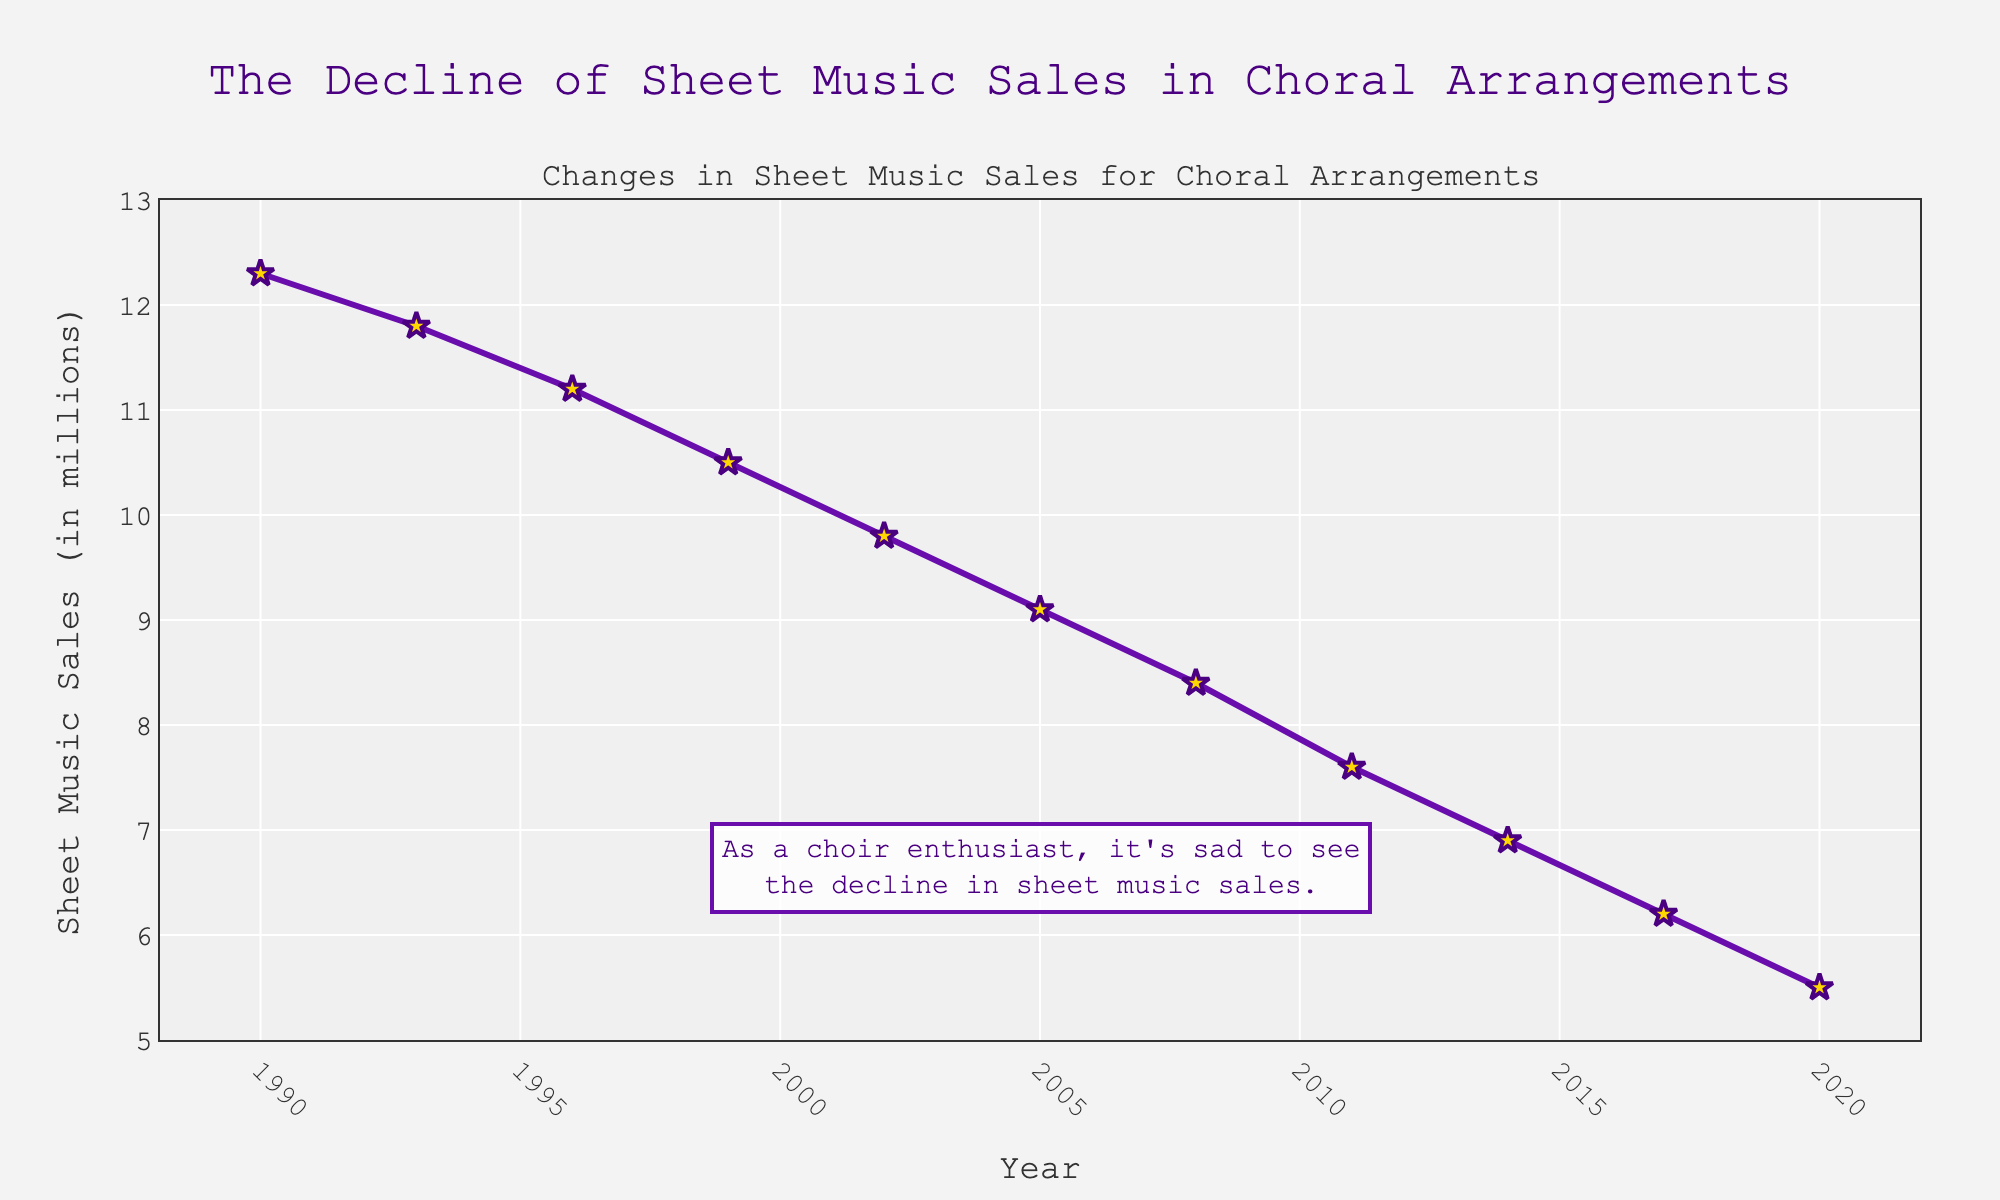What's the overall trend of sheet music sales for choral arrangements from 1990 to 2020? The overall trend of the sheet music sales for choral arrangements from 1990 to 2020 shows a consistent decline. By looking at the plotted line, it consistently drops over time.
Answer: Decline By how much did sheet music sales decrease between 1990 and 2020? In 1990, the sales were 12.3 million, and in 2020, they were 5.5 million. To find the decrease, subtract the 2020 value from the 1990 value: 12.3 - 5.5 = 6.8 million.
Answer: 6.8 million In which three-year period did sheet music sales decline the most, and by how much? Check the differences between sales every three years: 
1990-1993: 12.3 - 11.8 = 0.5 
1993-1996: 11.8 - 11.2 = 0.6 
1996-1999: 11.2 - 10.5 = 0.7 
1999-2002: 10.5 - 9.8 = 0.7 
2002-2005: 9.8 - 9.1 = 0.7 
2005-2008: 9.1 - 8.4 = 0.7 
2008-2011: 8.4 - 7.6 = 0.8 
2011-2014: 7.6 - 6.9 = 0.7 
2014-2017: 6.9 - 6.2 = 0.7 
2017-2020: 6.2 - 5.5 = 0.7 
The period with the largest decline is 2008-2011 with a decrease of 0.8 million.
Answer: 2008-2011, 0.8 million What is the average sheet music sales per year for the first decade (1990-2000)? Add the sales from each year in the first decade and divide by the number of years: 
(12.3 + 11.8 + 11.2 + 10.5 + 9.8) / 5 = 55.6 / 5 = 11.12 million.
Answer: 11.12 million How do the sales in 2002 compare to the sales in 1990? Compare the two values directly: In 2002, the sales were 9.8 million, and in 1990, the sales were 12.3 million. So, sales in 2002 are less than in 1990.
Answer: Less What is the percentage drop in sheet music sales from 2011 to 2020? First, calculate the drop: 7.6 - 5.5 = 2.1 million. Then, find the percentage drop relative to 2011 sales: (2.1 / 7.6) * 100 ≈ 27.63%.
Answer: 27.63% Which year experienced the smallest decrease in sheet music sales compared to its previous recorded year? Calculate the yearly decreases:
1990-1993: 12.3 - 11.8 = 0.5 
1993-1996: 11.8 - 11.2 = 0.6 
1996-1999: 11.2 - 10.5 = 0.7 
1999-2002: 10.5 - 9.8 = 0.7 
2002-2005: 9.8 - 9.1 = 0.7 
2005-2008: 9.1 - 8.4 = 0.7 
2008-2011: 8.4 - 7.6 = 0.8 
2011-2014: 7.6 - 6.9 = 0.7 
2014-2017: 6.9 - 6.2 = 0.7 
2017-2020: 6.2 - 5.5 = 0.7 
The smallest decrease is between 1990 and 1993 at 0.5 million.
Answer: 1990-1993 Overall, by what factor did sheet music sales drop from 1990 to 2020? Divide the sales in 1990 by the sales in 2020: 12.3 / 5.5 ≈ 2.24.
Answer: 2.24 